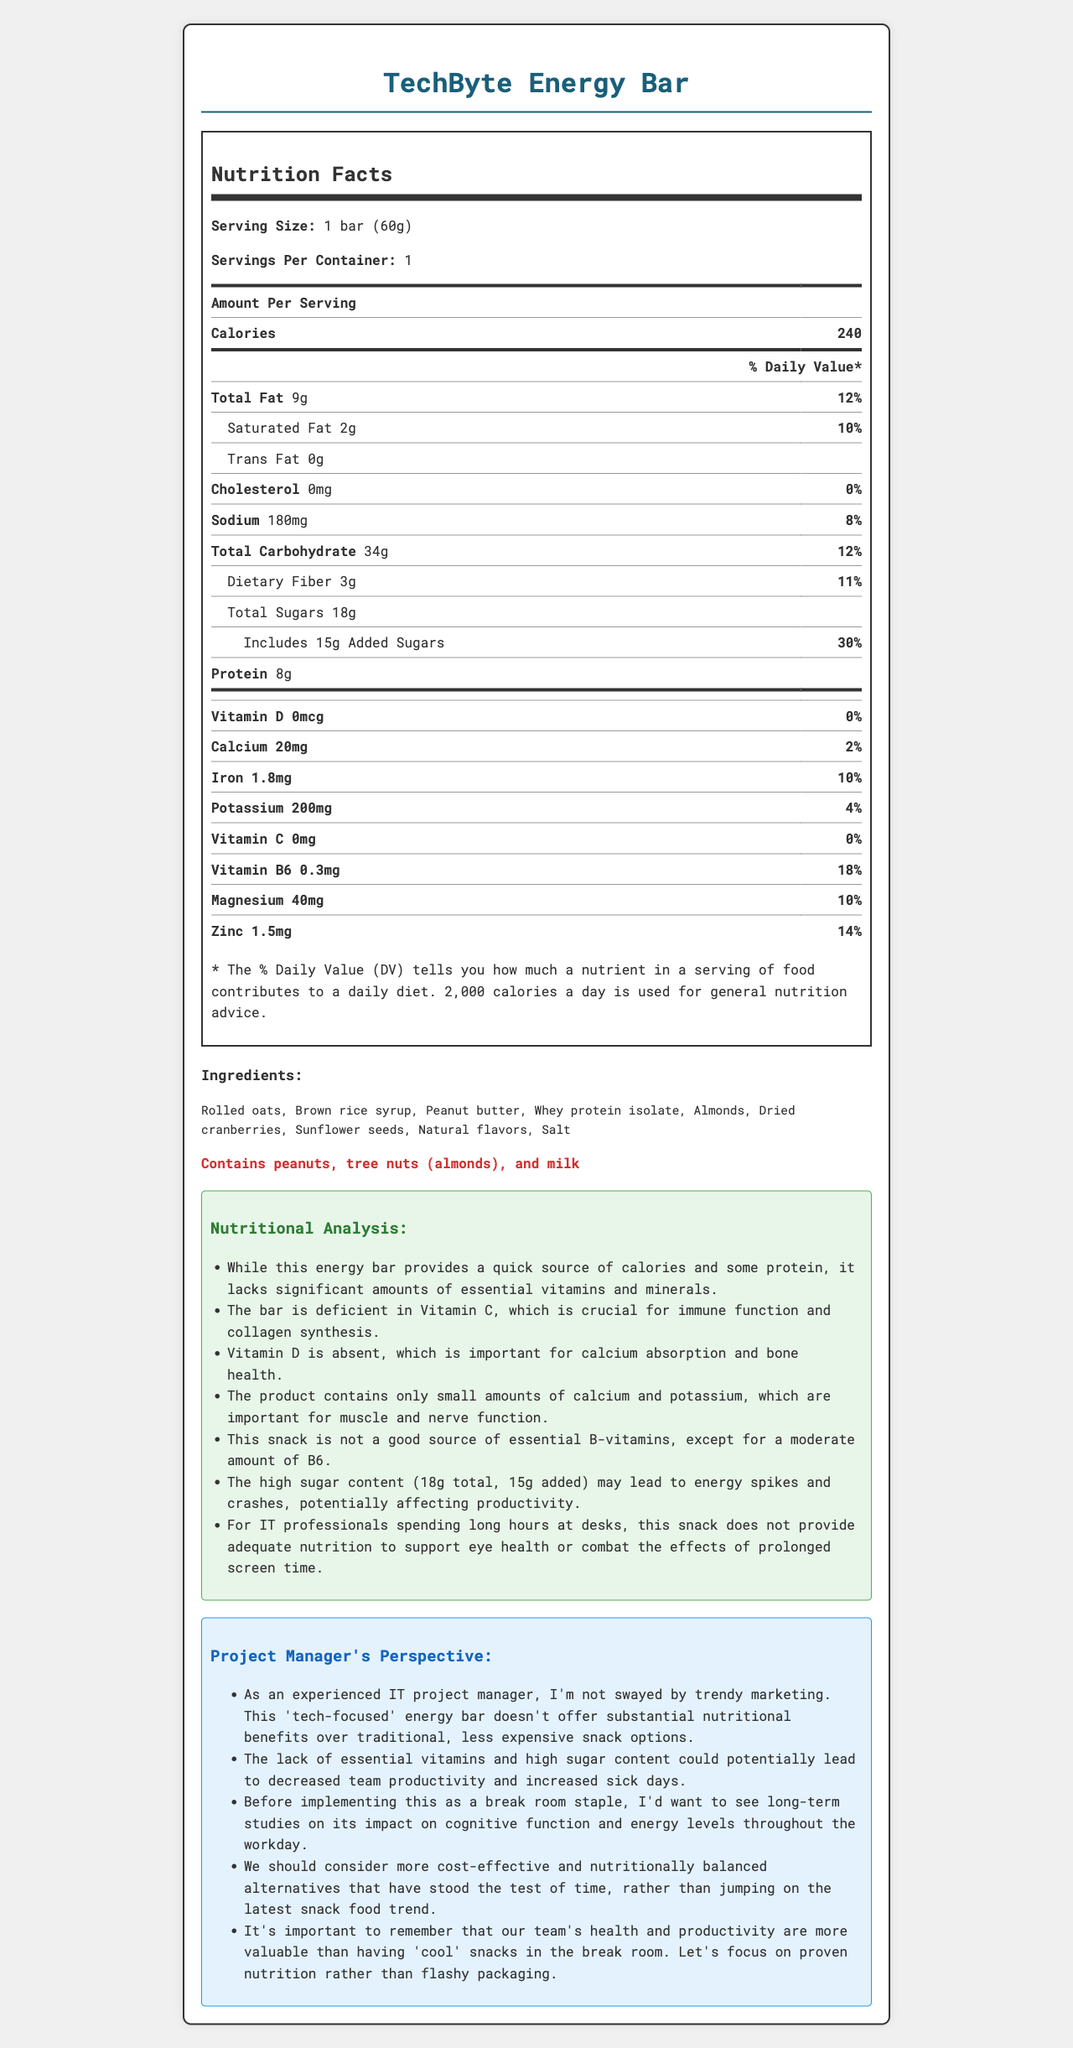what is the serving size of the TechByte Energy Bar? The document specifies the serving size directly under the product name and servings per container.
Answer: 1 bar (60g) how many calories are in one serving? The calorie count is listed in the Amount Per Serving section of the nutrition label.
Answer: 240 which micronutrient has the highest daily value percentage in the bar? The detailed micronutrient percentages listed in the nutrition label show that Vitamin B6 has a daily value of 18%, the highest among the listed vitamins and minerals.
Answer: Vitamin B6 what is the amount of total sugars in the TechByte Energy Bar? The amount of total sugars, including added sugars, is listed in the carbohydrate section of the nutrition label.
Answer: 18g does the TechByte Energy Bar contain any Vitamin D? The nutrition label shows that Vitamin D is 0 mcg, contributing 0% to the daily value.
Answer: No which micronutrient is completely absent from the TechByte Energy Bar? A. Vitamin C B. Magnesium C. Zinc D. Iron The nutrition label indicates that Vitamin C is 0 mg, 0% daily value, signaling its complete absence.
Answer: A which of these allergens is present in the TechByte Energy Bar? (Choose all that apply) I. Peanuts II. Tree nuts III. Milk IV. Soy The allergens section of the document lists peanuts, tree nuts (almonds), and milk.
Answer: I, II, III is the TechByte Energy Bar a good source of dietary fiber? The nutrition label denotes 3g of dietary fiber, approximately 11% of the daily value, which is considered a moderate amount.
Answer: Yes does the energy bar have any cholesterol? The label clearly states that cholesterol is 0 mg, contributing 0% to the daily value.
Answer: No what is the main insight from the project manager’s perspective on the energy bar? The project manager’s perspective section includes analysis highlighting the lack of essential vitamins, the high sugar content, and questioning the supposed cognitive benefits of the bar.
Answer: The energy bar does not offer substantial nutritional benefits and could impact productivity negatively due to its high sugar content and lack of essential vitamins. summarize the analysis notes provided in the document. The analysis notes detail the specific deficiencies of the energy bar, such as the absence of crucial vitamins, low calcium and potassium levels, and the potential negative effects of high sugar content on energy and health.
Answer: The TechByte Energy Bar is lacking in essential vitamins and minerals, including Vitamin C and Vitamin D. It has small amounts of calcium and potassium, moderate Vitamin B6, and high sugar content. These factors can lead to health issues for IT professionals. what are the natural flavors used in the TechByte Energy Bar? The document lists "natural flavors" as an ingredient but does not specify which natural flavors are used.
Answer: Not enough information 